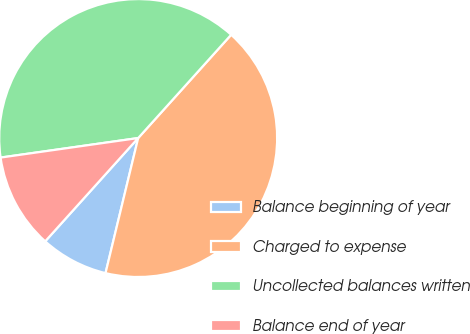<chart> <loc_0><loc_0><loc_500><loc_500><pie_chart><fcel>Balance beginning of year<fcel>Charged to expense<fcel>Uncollected balances written<fcel>Balance end of year<nl><fcel>7.89%<fcel>42.11%<fcel>38.91%<fcel>11.09%<nl></chart> 